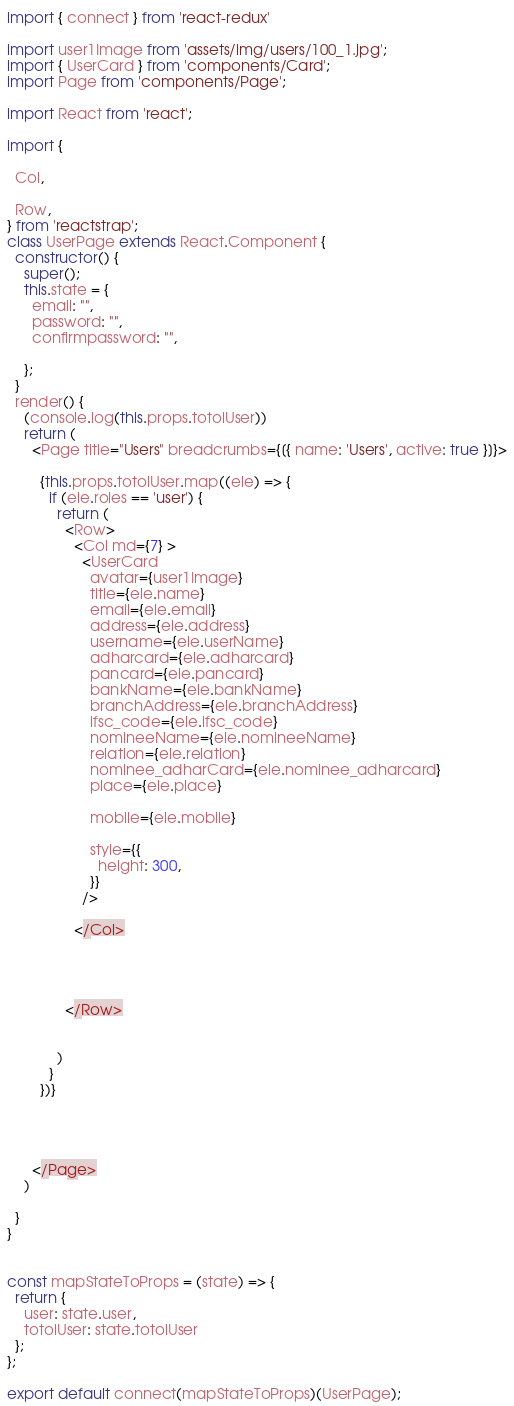<code> <loc_0><loc_0><loc_500><loc_500><_JavaScript_>
import { connect } from 'react-redux'

import user1Image from 'assets/img/users/100_1.jpg';
import { UserCard } from 'components/Card';
import Page from 'components/Page';

import React from 'react';

import {

  Col,

  Row,
} from 'reactstrap';
class UserPage extends React.Component {
  constructor() {
    super();
    this.state = {
      email: "",
      password: "",
      confirmpassword: "",

    };
  }
  render() {
    (console.log(this.props.totolUser))
    return (
      <Page title="Users" breadcrumbs={[{ name: 'Users', active: true }]}>

        {this.props.totolUser.map((ele) => {
          if (ele.roles == 'user') {
            return (
              <Row>
                <Col md={7} >
                  <UserCard
                    avatar={user1Image}
                    title={ele.name}
                    email={ele.email}
                    address={ele.address}
                    username={ele.userName}
                    adharcard={ele.adharcard}
                    pancard={ele.pancard}
                    bankName={ele.bankName}
                    branchAddress={ele.branchAddress}
                    ifsc_code={ele.ifsc_code}
                    nomineeName={ele.nomineeName}
                    relation={ele.relation}
                    nominee_adharCard={ele.nominee_adharcard}
                    place={ele.place}

                    mobile={ele.mobile}

                    style={{
                      height: 300,
                    }}
                  />

                </Col>




              </Row>


            )
          }
        })}




      </Page>
    )

  }
}


const mapStateToProps = (state) => {
  return {
    user: state.user,
    totolUser: state.totolUser
  };
};

export default connect(mapStateToProps)(UserPage);
</code> 